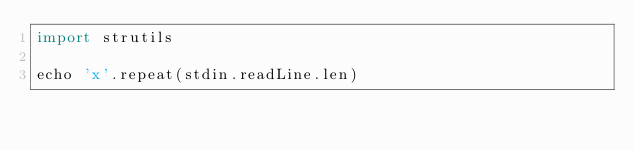<code> <loc_0><loc_0><loc_500><loc_500><_Nim_>import strutils

echo 'x'.repeat(stdin.readLine.len)
</code> 